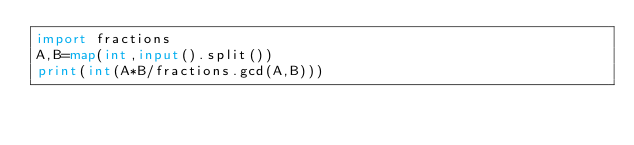Convert code to text. <code><loc_0><loc_0><loc_500><loc_500><_Python_>import fractions
A,B=map(int,input().split())
print(int(A*B/fractions.gcd(A,B)))</code> 